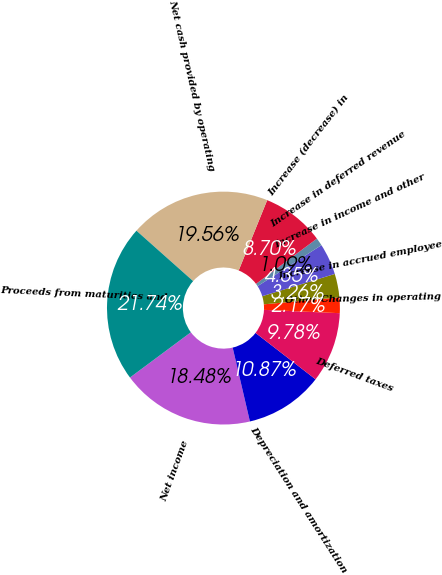<chart> <loc_0><loc_0><loc_500><loc_500><pie_chart><fcel>Net income<fcel>Depreciation and amortization<fcel>Deferred taxes<fcel>Other Changes in operating<fcel>Increase in accrued employee<fcel>Increase in income and other<fcel>Increase in deferred revenue<fcel>Increase (decrease) in<fcel>Net cash provided by operating<fcel>Proceeds from maturities and<nl><fcel>18.48%<fcel>10.87%<fcel>9.78%<fcel>2.17%<fcel>3.26%<fcel>4.35%<fcel>1.09%<fcel>8.7%<fcel>19.56%<fcel>21.74%<nl></chart> 